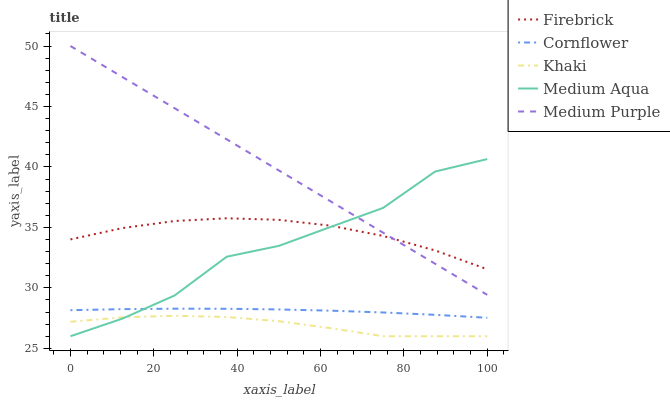Does Khaki have the minimum area under the curve?
Answer yes or no. Yes. Does Medium Purple have the maximum area under the curve?
Answer yes or no. Yes. Does Cornflower have the minimum area under the curve?
Answer yes or no. No. Does Cornflower have the maximum area under the curve?
Answer yes or no. No. Is Medium Purple the smoothest?
Answer yes or no. Yes. Is Medium Aqua the roughest?
Answer yes or no. Yes. Is Cornflower the smoothest?
Answer yes or no. No. Is Cornflower the roughest?
Answer yes or no. No. Does Khaki have the lowest value?
Answer yes or no. Yes. Does Cornflower have the lowest value?
Answer yes or no. No. Does Medium Purple have the highest value?
Answer yes or no. Yes. Does Cornflower have the highest value?
Answer yes or no. No. Is Khaki less than Firebrick?
Answer yes or no. Yes. Is Cornflower greater than Khaki?
Answer yes or no. Yes. Does Firebrick intersect Medium Aqua?
Answer yes or no. Yes. Is Firebrick less than Medium Aqua?
Answer yes or no. No. Is Firebrick greater than Medium Aqua?
Answer yes or no. No. Does Khaki intersect Firebrick?
Answer yes or no. No. 